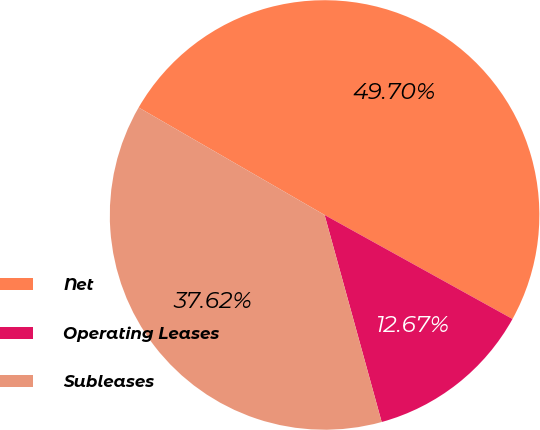Convert chart. <chart><loc_0><loc_0><loc_500><loc_500><pie_chart><fcel>Net<fcel>Operating Leases<fcel>Subleases<nl><fcel>49.7%<fcel>12.67%<fcel>37.62%<nl></chart> 